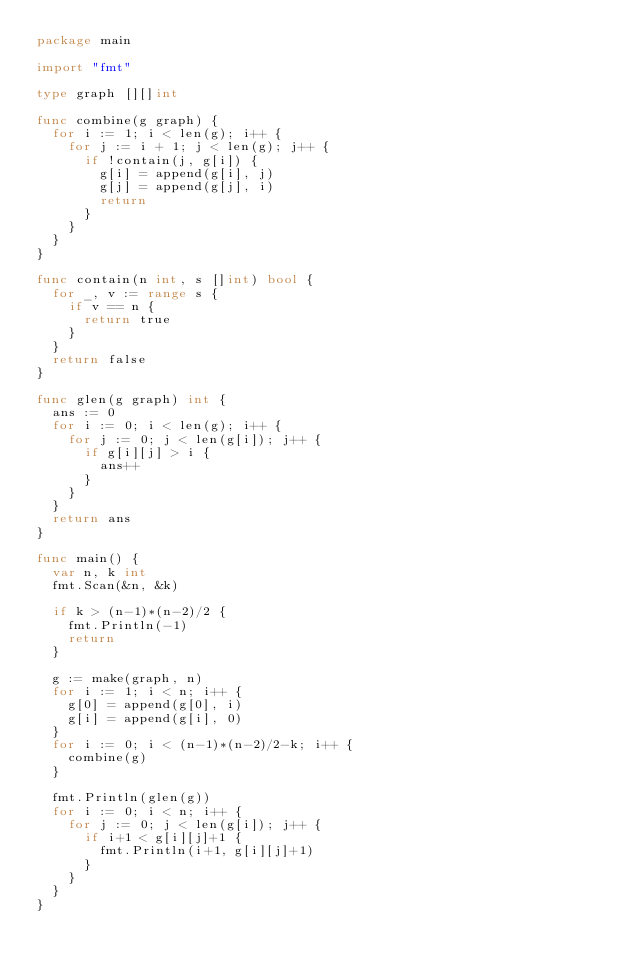<code> <loc_0><loc_0><loc_500><loc_500><_Go_>package main

import "fmt"

type graph [][]int

func combine(g graph) {
	for i := 1; i < len(g); i++ {
		for j := i + 1; j < len(g); j++ {
			if !contain(j, g[i]) {
				g[i] = append(g[i], j)
				g[j] = append(g[j], i)
				return
			}
		}
	}
}

func contain(n int, s []int) bool {
	for _, v := range s {
		if v == n {
			return true
		}
	}
	return false
}

func glen(g graph) int {
	ans := 0
	for i := 0; i < len(g); i++ {
		for j := 0; j < len(g[i]); j++ {
			if g[i][j] > i {
				ans++
			}
		}
	}
	return ans
}

func main() {
	var n, k int
	fmt.Scan(&n, &k)

	if k > (n-1)*(n-2)/2 {
		fmt.Println(-1)
		return
	}

	g := make(graph, n)
	for i := 1; i < n; i++ {
		g[0] = append(g[0], i)
		g[i] = append(g[i], 0)
	}
	for i := 0; i < (n-1)*(n-2)/2-k; i++ {
		combine(g)
	}

	fmt.Println(glen(g))
	for i := 0; i < n; i++ {
		for j := 0; j < len(g[i]); j++ {
			if i+1 < g[i][j]+1 {
				fmt.Println(i+1, g[i][j]+1)
			}
		}
	}
}
</code> 